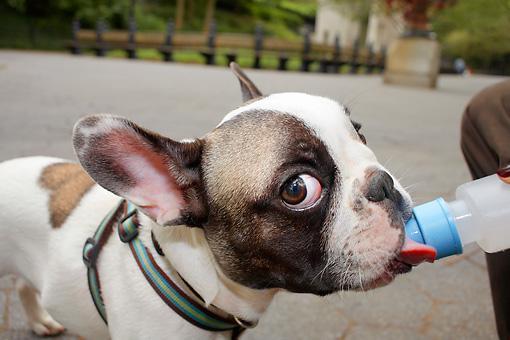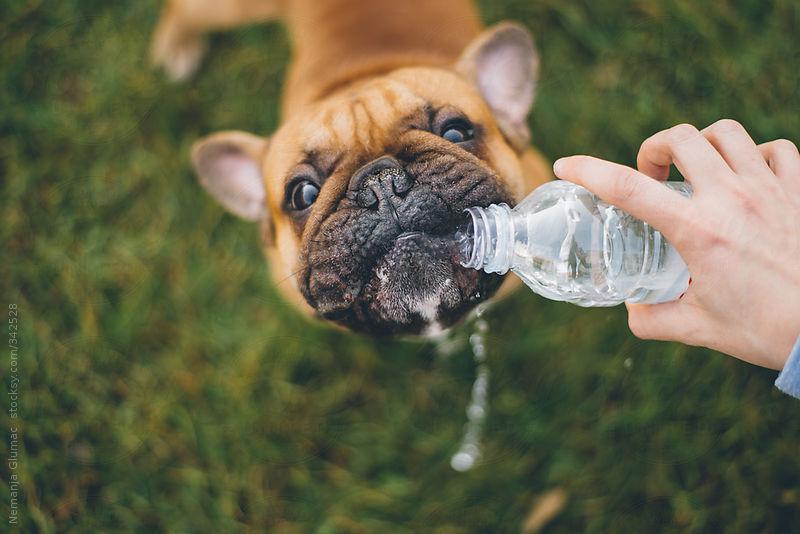The first image is the image on the left, the second image is the image on the right. Given the left and right images, does the statement "The left image contains at least two dogs." hold true? Answer yes or no. No. The first image is the image on the left, the second image is the image on the right. For the images displayed, is the sentence "A stout brown-and-white bulldog is by himself in a blue kiddie pool in one image, and the other image shows a dog that is above the water of a larger swimming pool." factually correct? Answer yes or no. No. 